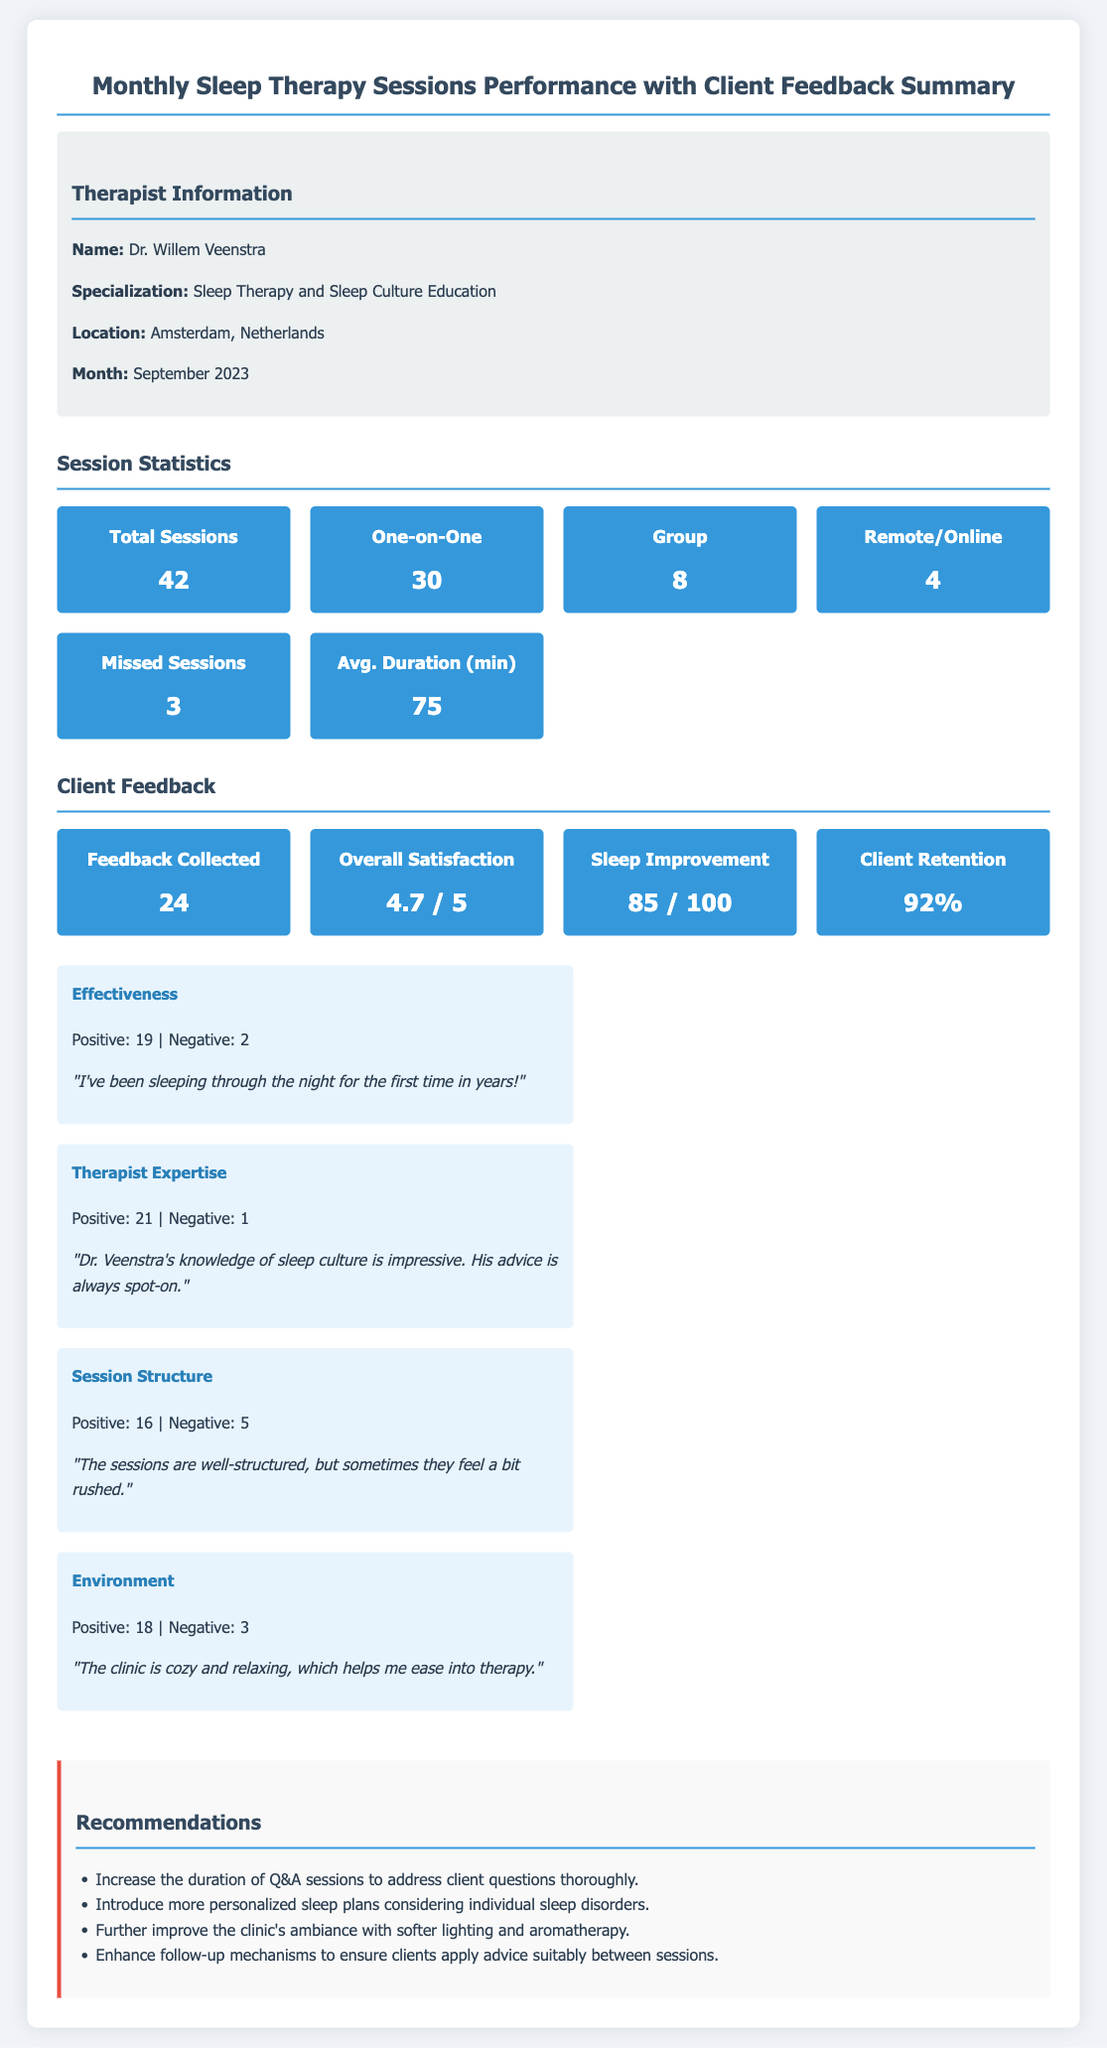What is the total number of sessions conducted? The total number of sessions is indicated in the statistics section of the document.
Answer: 42 What is the average duration of the sessions in minutes? The average duration of the sessions is listed under the session statistics section.
Answer: 75 What is the overall client satisfaction rating? Overall satisfaction is provided in the client feedback section as a rating.
Answer: 4.7 / 5 How many clients provided feedback? The number of feedback responses collected is noted in the client feedback section.
Answer: 24 What percentage of clients were retained? Client retention is displayed as a percentage in the client feedback section.
Answer: 92% What recommendation is made regarding session duration? Recommendations provided at the end include suggestions for session improvements.
Answer: Increase the duration of Q&A sessions to address client questions thoroughly 